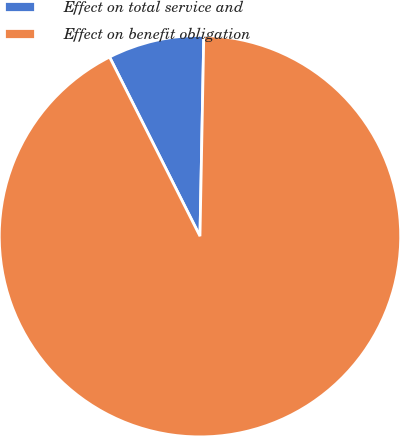<chart> <loc_0><loc_0><loc_500><loc_500><pie_chart><fcel>Effect on total service and<fcel>Effect on benefit obligation<nl><fcel>7.74%<fcel>92.26%<nl></chart> 